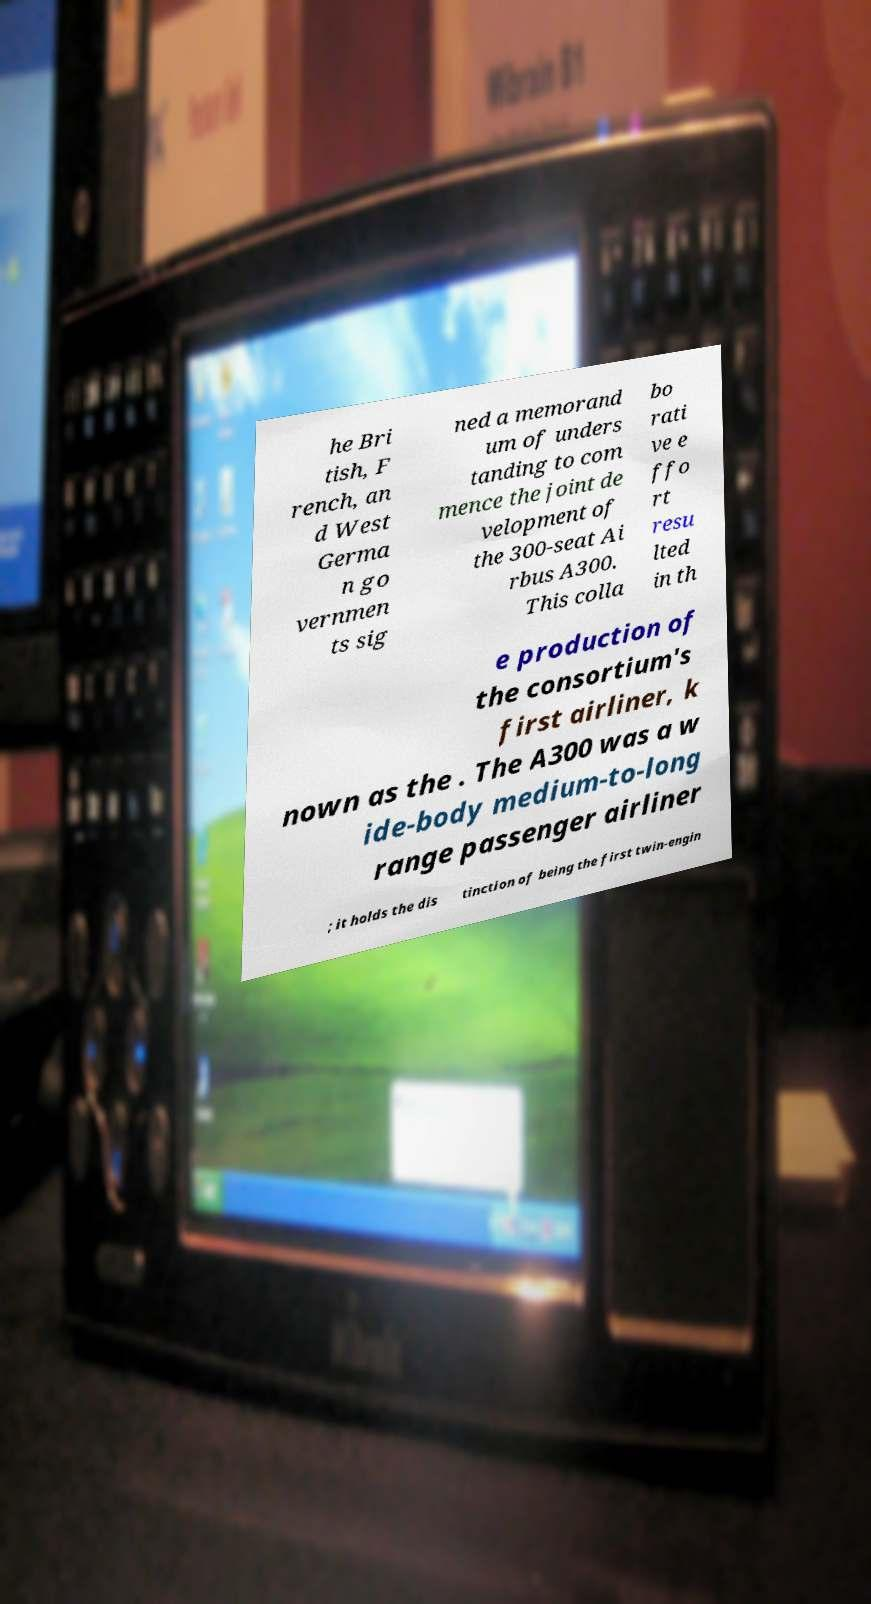I need the written content from this picture converted into text. Can you do that? he Bri tish, F rench, an d West Germa n go vernmen ts sig ned a memorand um of unders tanding to com mence the joint de velopment of the 300-seat Ai rbus A300. This colla bo rati ve e ffo rt resu lted in th e production of the consortium's first airliner, k nown as the . The A300 was a w ide-body medium-to-long range passenger airliner ; it holds the dis tinction of being the first twin-engin 